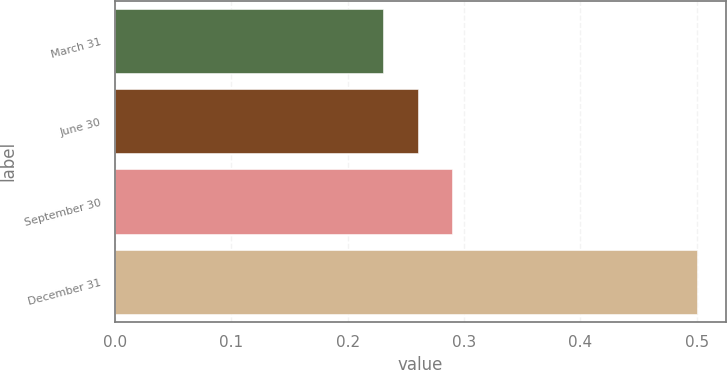Convert chart to OTSL. <chart><loc_0><loc_0><loc_500><loc_500><bar_chart><fcel>March 31<fcel>June 30<fcel>September 30<fcel>December 31<nl><fcel>0.23<fcel>0.26<fcel>0.29<fcel>0.5<nl></chart> 